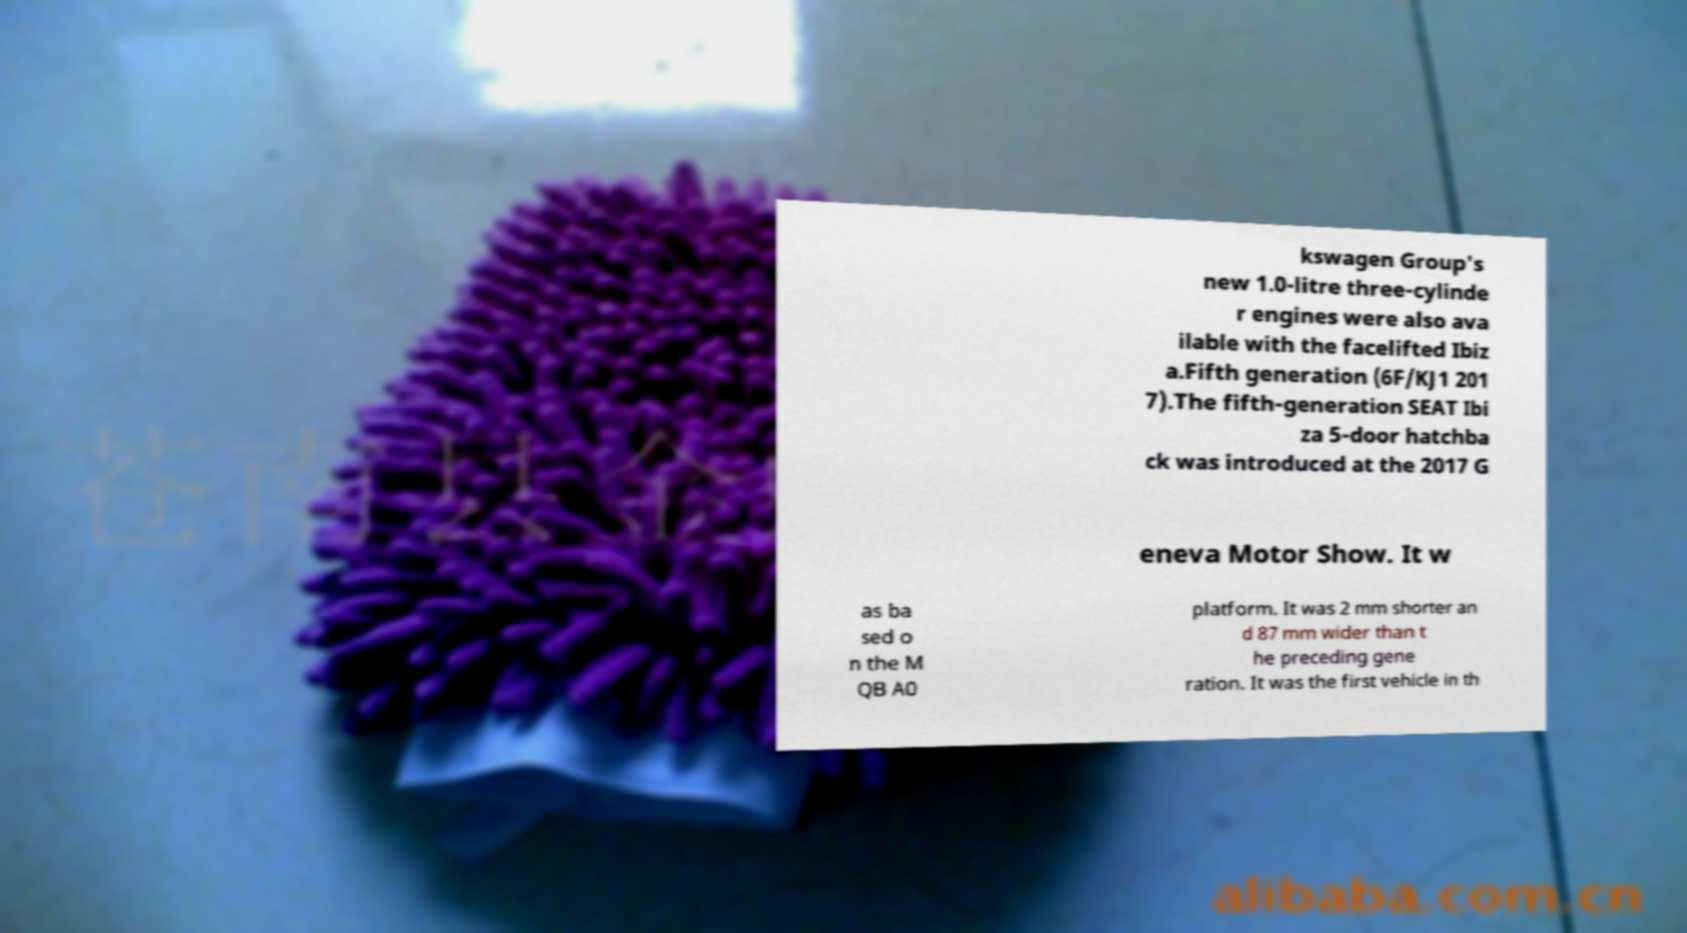Can you read and provide the text displayed in the image?This photo seems to have some interesting text. Can you extract and type it out for me? kswagen Group's new 1.0-litre three-cylinde r engines were also ava ilable with the facelifted Ibiz a.Fifth generation (6F/KJ1 201 7).The fifth-generation SEAT Ibi za 5-door hatchba ck was introduced at the 2017 G eneva Motor Show. It w as ba sed o n the M QB A0 platform. It was 2 mm shorter an d 87 mm wider than t he preceding gene ration. It was the first vehicle in th 